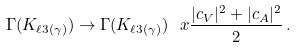<formula> <loc_0><loc_0><loc_500><loc_500>\Gamma ( K _ { \ell 3 ( \gamma ) } ) \to \Gamma ( K _ { \ell 3 ( \gamma ) } ) \ x \frac { | c _ { V } | ^ { 2 } + | c _ { A } | ^ { 2 } } { 2 } \, .</formula> 